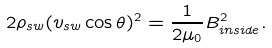<formula> <loc_0><loc_0><loc_500><loc_500>2 \rho _ { s w } ( v _ { s w } \cos { \theta } ) ^ { 2 } = \frac { 1 } { 2 \mu _ { 0 } } B _ { i n s i d e } ^ { 2 } .</formula> 